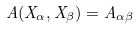Convert formula to latex. <formula><loc_0><loc_0><loc_500><loc_500>A ( X _ { \alpha } , X _ { \beta } ) = A _ { \alpha \beta }</formula> 